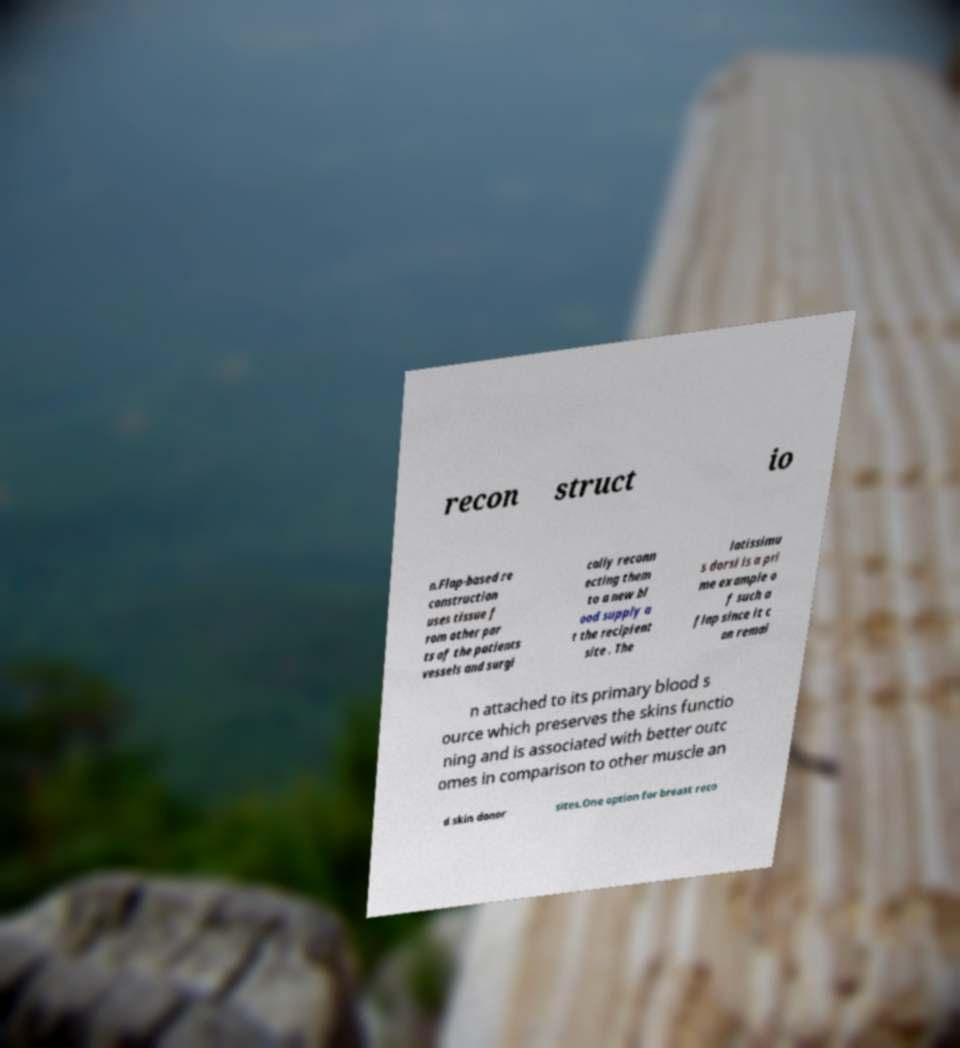I need the written content from this picture converted into text. Can you do that? recon struct io n.Flap-based re construction uses tissue f rom other par ts of the patients vessels and surgi cally reconn ecting them to a new bl ood supply a t the recipient site . The latissimu s dorsi is a pri me example o f such a flap since it c an remai n attached to its primary blood s ource which preserves the skins functio ning and is associated with better outc omes in comparison to other muscle an d skin donor sites.One option for breast reco 